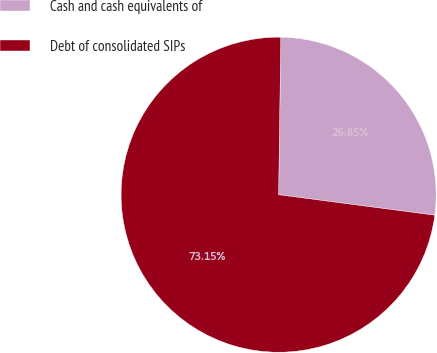Convert chart to OTSL. <chart><loc_0><loc_0><loc_500><loc_500><pie_chart><fcel>Cash and cash equivalents of<fcel>Debt of consolidated SIPs<nl><fcel>26.85%<fcel>73.15%<nl></chart> 